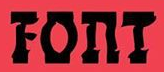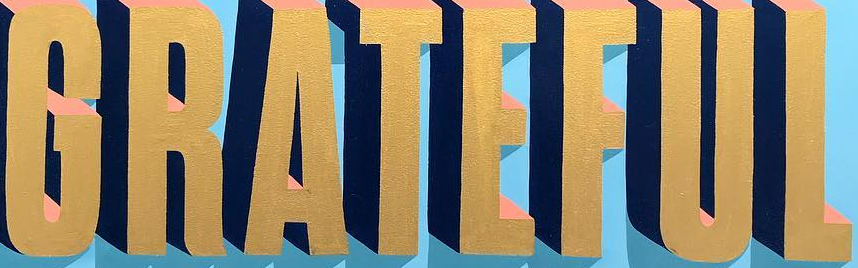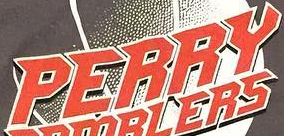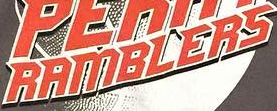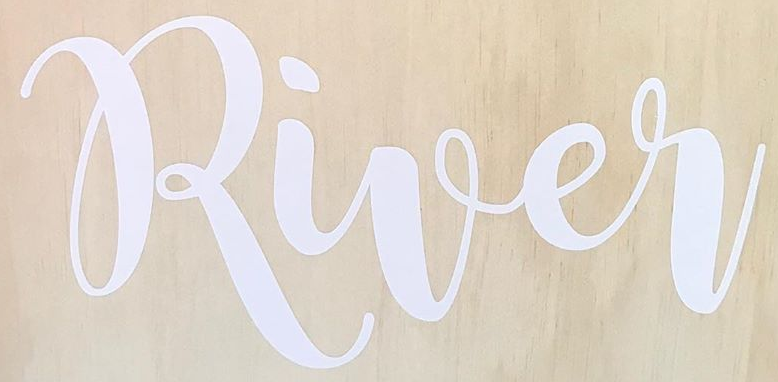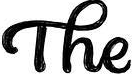What text appears in these images from left to right, separated by a semicolon? FOnT; GRATEFUL; PERRY; RAMBLERS; River; The 